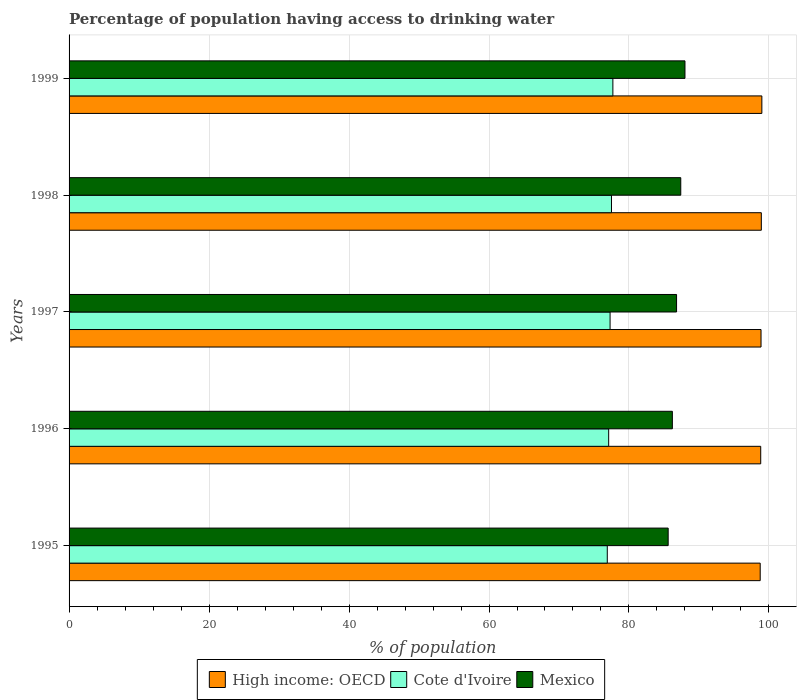Are the number of bars per tick equal to the number of legend labels?
Give a very brief answer. Yes. What is the label of the 5th group of bars from the top?
Ensure brevity in your answer.  1995. What is the percentage of population having access to drinking water in High income: OECD in 1999?
Your response must be concise. 98.99. Across all years, what is the maximum percentage of population having access to drinking water in Mexico?
Make the answer very short. 88. Across all years, what is the minimum percentage of population having access to drinking water in Mexico?
Make the answer very short. 85.6. In which year was the percentage of population having access to drinking water in High income: OECD maximum?
Provide a succinct answer. 1999. In which year was the percentage of population having access to drinking water in High income: OECD minimum?
Your response must be concise. 1995. What is the total percentage of population having access to drinking water in Cote d'Ivoire in the graph?
Your answer should be very brief. 386.5. What is the difference between the percentage of population having access to drinking water in Cote d'Ivoire in 1996 and that in 1999?
Your answer should be very brief. -0.6. What is the difference between the percentage of population having access to drinking water in Mexico in 1997 and the percentage of population having access to drinking water in High income: OECD in 1999?
Provide a succinct answer. -12.19. What is the average percentage of population having access to drinking water in Cote d'Ivoire per year?
Give a very brief answer. 77.3. In the year 1999, what is the difference between the percentage of population having access to drinking water in High income: OECD and percentage of population having access to drinking water in Mexico?
Your response must be concise. 10.99. What is the ratio of the percentage of population having access to drinking water in High income: OECD in 1995 to that in 1999?
Make the answer very short. 1. What is the difference between the highest and the second highest percentage of population having access to drinking water in Cote d'Ivoire?
Your answer should be very brief. 0.2. What is the difference between the highest and the lowest percentage of population having access to drinking water in Mexico?
Keep it short and to the point. 2.4. Is the sum of the percentage of population having access to drinking water in High income: OECD in 1998 and 1999 greater than the maximum percentage of population having access to drinking water in Mexico across all years?
Provide a short and direct response. Yes. What does the 1st bar from the top in 1996 represents?
Offer a terse response. Mexico. What does the 1st bar from the bottom in 1997 represents?
Your answer should be compact. High income: OECD. Is it the case that in every year, the sum of the percentage of population having access to drinking water in Mexico and percentage of population having access to drinking water in High income: OECD is greater than the percentage of population having access to drinking water in Cote d'Ivoire?
Your answer should be compact. Yes. How many bars are there?
Ensure brevity in your answer.  15. Are all the bars in the graph horizontal?
Give a very brief answer. Yes. How many years are there in the graph?
Your answer should be very brief. 5. Does the graph contain any zero values?
Offer a very short reply. No. Does the graph contain grids?
Your answer should be compact. Yes. Where does the legend appear in the graph?
Your response must be concise. Bottom center. What is the title of the graph?
Your answer should be very brief. Percentage of population having access to drinking water. What is the label or title of the X-axis?
Provide a succinct answer. % of population. What is the % of population in High income: OECD in 1995?
Provide a succinct answer. 98.75. What is the % of population in Cote d'Ivoire in 1995?
Your answer should be compact. 76.9. What is the % of population of Mexico in 1995?
Your response must be concise. 85.6. What is the % of population in High income: OECD in 1996?
Your answer should be compact. 98.82. What is the % of population of Cote d'Ivoire in 1996?
Ensure brevity in your answer.  77.1. What is the % of population of Mexico in 1996?
Keep it short and to the point. 86.2. What is the % of population of High income: OECD in 1997?
Your answer should be very brief. 98.87. What is the % of population of Cote d'Ivoire in 1997?
Provide a succinct answer. 77.3. What is the % of population of Mexico in 1997?
Your answer should be compact. 86.8. What is the % of population in High income: OECD in 1998?
Make the answer very short. 98.91. What is the % of population in Cote d'Ivoire in 1998?
Your answer should be compact. 77.5. What is the % of population of Mexico in 1998?
Give a very brief answer. 87.4. What is the % of population in High income: OECD in 1999?
Offer a very short reply. 98.99. What is the % of population of Cote d'Ivoire in 1999?
Keep it short and to the point. 77.7. Across all years, what is the maximum % of population in High income: OECD?
Offer a very short reply. 98.99. Across all years, what is the maximum % of population in Cote d'Ivoire?
Offer a very short reply. 77.7. Across all years, what is the maximum % of population of Mexico?
Your response must be concise. 88. Across all years, what is the minimum % of population in High income: OECD?
Make the answer very short. 98.75. Across all years, what is the minimum % of population in Cote d'Ivoire?
Your answer should be compact. 76.9. Across all years, what is the minimum % of population of Mexico?
Your response must be concise. 85.6. What is the total % of population of High income: OECD in the graph?
Ensure brevity in your answer.  494.34. What is the total % of population of Cote d'Ivoire in the graph?
Your response must be concise. 386.5. What is the total % of population of Mexico in the graph?
Your response must be concise. 434. What is the difference between the % of population of High income: OECD in 1995 and that in 1996?
Ensure brevity in your answer.  -0.07. What is the difference between the % of population in Mexico in 1995 and that in 1996?
Offer a terse response. -0.6. What is the difference between the % of population in High income: OECD in 1995 and that in 1997?
Your answer should be compact. -0.12. What is the difference between the % of population in Mexico in 1995 and that in 1997?
Make the answer very short. -1.2. What is the difference between the % of population of High income: OECD in 1995 and that in 1998?
Provide a short and direct response. -0.16. What is the difference between the % of population in Cote d'Ivoire in 1995 and that in 1998?
Your answer should be very brief. -0.6. What is the difference between the % of population of Mexico in 1995 and that in 1998?
Provide a short and direct response. -1.8. What is the difference between the % of population in High income: OECD in 1995 and that in 1999?
Ensure brevity in your answer.  -0.24. What is the difference between the % of population of High income: OECD in 1996 and that in 1997?
Offer a terse response. -0.05. What is the difference between the % of population of High income: OECD in 1996 and that in 1998?
Provide a short and direct response. -0.09. What is the difference between the % of population in Cote d'Ivoire in 1996 and that in 1998?
Provide a short and direct response. -0.4. What is the difference between the % of population of Mexico in 1996 and that in 1998?
Offer a very short reply. -1.2. What is the difference between the % of population in High income: OECD in 1996 and that in 1999?
Provide a short and direct response. -0.16. What is the difference between the % of population in High income: OECD in 1997 and that in 1998?
Your answer should be compact. -0.04. What is the difference between the % of population of Cote d'Ivoire in 1997 and that in 1998?
Give a very brief answer. -0.2. What is the difference between the % of population in High income: OECD in 1997 and that in 1999?
Provide a short and direct response. -0.12. What is the difference between the % of population of Cote d'Ivoire in 1997 and that in 1999?
Offer a very short reply. -0.4. What is the difference between the % of population in High income: OECD in 1998 and that in 1999?
Ensure brevity in your answer.  -0.08. What is the difference between the % of population in Cote d'Ivoire in 1998 and that in 1999?
Offer a terse response. -0.2. What is the difference between the % of population in Mexico in 1998 and that in 1999?
Your answer should be compact. -0.6. What is the difference between the % of population in High income: OECD in 1995 and the % of population in Cote d'Ivoire in 1996?
Your answer should be compact. 21.65. What is the difference between the % of population in High income: OECD in 1995 and the % of population in Mexico in 1996?
Provide a short and direct response. 12.55. What is the difference between the % of population of High income: OECD in 1995 and the % of population of Cote d'Ivoire in 1997?
Provide a short and direct response. 21.45. What is the difference between the % of population of High income: OECD in 1995 and the % of population of Mexico in 1997?
Offer a very short reply. 11.95. What is the difference between the % of population of Cote d'Ivoire in 1995 and the % of population of Mexico in 1997?
Ensure brevity in your answer.  -9.9. What is the difference between the % of population in High income: OECD in 1995 and the % of population in Cote d'Ivoire in 1998?
Keep it short and to the point. 21.25. What is the difference between the % of population in High income: OECD in 1995 and the % of population in Mexico in 1998?
Give a very brief answer. 11.35. What is the difference between the % of population in High income: OECD in 1995 and the % of population in Cote d'Ivoire in 1999?
Your answer should be compact. 21.05. What is the difference between the % of population of High income: OECD in 1995 and the % of population of Mexico in 1999?
Provide a succinct answer. 10.75. What is the difference between the % of population of High income: OECD in 1996 and the % of population of Cote d'Ivoire in 1997?
Make the answer very short. 21.52. What is the difference between the % of population in High income: OECD in 1996 and the % of population in Mexico in 1997?
Provide a succinct answer. 12.02. What is the difference between the % of population in High income: OECD in 1996 and the % of population in Cote d'Ivoire in 1998?
Your answer should be very brief. 21.32. What is the difference between the % of population in High income: OECD in 1996 and the % of population in Mexico in 1998?
Provide a short and direct response. 11.42. What is the difference between the % of population in High income: OECD in 1996 and the % of population in Cote d'Ivoire in 1999?
Make the answer very short. 21.12. What is the difference between the % of population of High income: OECD in 1996 and the % of population of Mexico in 1999?
Give a very brief answer. 10.82. What is the difference between the % of population in Cote d'Ivoire in 1996 and the % of population in Mexico in 1999?
Give a very brief answer. -10.9. What is the difference between the % of population in High income: OECD in 1997 and the % of population in Cote d'Ivoire in 1998?
Your response must be concise. 21.37. What is the difference between the % of population of High income: OECD in 1997 and the % of population of Mexico in 1998?
Make the answer very short. 11.47. What is the difference between the % of population in High income: OECD in 1997 and the % of population in Cote d'Ivoire in 1999?
Make the answer very short. 21.17. What is the difference between the % of population of High income: OECD in 1997 and the % of population of Mexico in 1999?
Ensure brevity in your answer.  10.87. What is the difference between the % of population in Cote d'Ivoire in 1997 and the % of population in Mexico in 1999?
Offer a very short reply. -10.7. What is the difference between the % of population of High income: OECD in 1998 and the % of population of Cote d'Ivoire in 1999?
Ensure brevity in your answer.  21.21. What is the difference between the % of population of High income: OECD in 1998 and the % of population of Mexico in 1999?
Give a very brief answer. 10.91. What is the difference between the % of population in Cote d'Ivoire in 1998 and the % of population in Mexico in 1999?
Offer a terse response. -10.5. What is the average % of population of High income: OECD per year?
Offer a terse response. 98.87. What is the average % of population of Cote d'Ivoire per year?
Provide a succinct answer. 77.3. What is the average % of population of Mexico per year?
Ensure brevity in your answer.  86.8. In the year 1995, what is the difference between the % of population of High income: OECD and % of population of Cote d'Ivoire?
Your answer should be compact. 21.85. In the year 1995, what is the difference between the % of population in High income: OECD and % of population in Mexico?
Give a very brief answer. 13.15. In the year 1995, what is the difference between the % of population of Cote d'Ivoire and % of population of Mexico?
Offer a terse response. -8.7. In the year 1996, what is the difference between the % of population of High income: OECD and % of population of Cote d'Ivoire?
Your answer should be compact. 21.72. In the year 1996, what is the difference between the % of population in High income: OECD and % of population in Mexico?
Offer a very short reply. 12.62. In the year 1997, what is the difference between the % of population in High income: OECD and % of population in Cote d'Ivoire?
Give a very brief answer. 21.57. In the year 1997, what is the difference between the % of population of High income: OECD and % of population of Mexico?
Ensure brevity in your answer.  12.07. In the year 1998, what is the difference between the % of population in High income: OECD and % of population in Cote d'Ivoire?
Give a very brief answer. 21.41. In the year 1998, what is the difference between the % of population in High income: OECD and % of population in Mexico?
Ensure brevity in your answer.  11.51. In the year 1999, what is the difference between the % of population in High income: OECD and % of population in Cote d'Ivoire?
Your response must be concise. 21.29. In the year 1999, what is the difference between the % of population in High income: OECD and % of population in Mexico?
Your answer should be very brief. 10.99. In the year 1999, what is the difference between the % of population of Cote d'Ivoire and % of population of Mexico?
Your answer should be compact. -10.3. What is the ratio of the % of population of High income: OECD in 1995 to that in 1996?
Make the answer very short. 1. What is the ratio of the % of population in High income: OECD in 1995 to that in 1997?
Your answer should be compact. 1. What is the ratio of the % of population of Cote d'Ivoire in 1995 to that in 1997?
Provide a succinct answer. 0.99. What is the ratio of the % of population of Mexico in 1995 to that in 1997?
Give a very brief answer. 0.99. What is the ratio of the % of population in High income: OECD in 1995 to that in 1998?
Your response must be concise. 1. What is the ratio of the % of population of Cote d'Ivoire in 1995 to that in 1998?
Ensure brevity in your answer.  0.99. What is the ratio of the % of population of Mexico in 1995 to that in 1998?
Keep it short and to the point. 0.98. What is the ratio of the % of population of High income: OECD in 1995 to that in 1999?
Give a very brief answer. 1. What is the ratio of the % of population in Mexico in 1995 to that in 1999?
Your response must be concise. 0.97. What is the ratio of the % of population of Cote d'Ivoire in 1996 to that in 1998?
Your answer should be compact. 0.99. What is the ratio of the % of population in Mexico in 1996 to that in 1998?
Offer a terse response. 0.99. What is the ratio of the % of population of High income: OECD in 1996 to that in 1999?
Keep it short and to the point. 1. What is the ratio of the % of population in Mexico in 1996 to that in 1999?
Offer a terse response. 0.98. What is the ratio of the % of population of High income: OECD in 1997 to that in 1998?
Provide a succinct answer. 1. What is the ratio of the % of population in High income: OECD in 1997 to that in 1999?
Offer a terse response. 1. What is the ratio of the % of population in Mexico in 1997 to that in 1999?
Your answer should be very brief. 0.99. What is the ratio of the % of population of Mexico in 1998 to that in 1999?
Provide a short and direct response. 0.99. What is the difference between the highest and the second highest % of population in High income: OECD?
Ensure brevity in your answer.  0.08. What is the difference between the highest and the second highest % of population of Cote d'Ivoire?
Keep it short and to the point. 0.2. What is the difference between the highest and the lowest % of population in High income: OECD?
Your answer should be very brief. 0.24. What is the difference between the highest and the lowest % of population in Cote d'Ivoire?
Offer a very short reply. 0.8. 